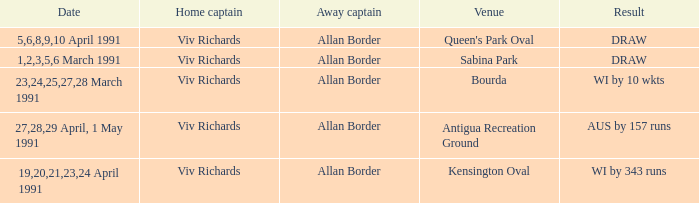Which venues resulted in a draw? Sabina Park, Queen's Park Oval. 